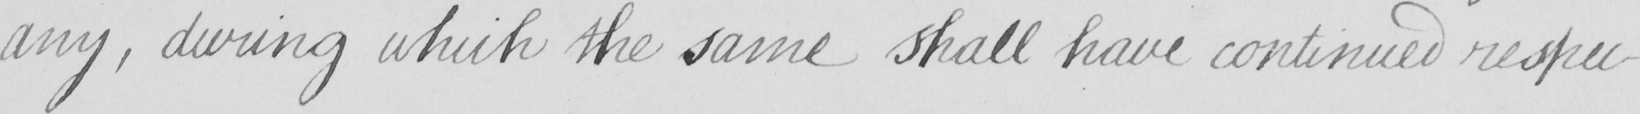Can you read and transcribe this handwriting? any , during which the same shall have continued respec- 